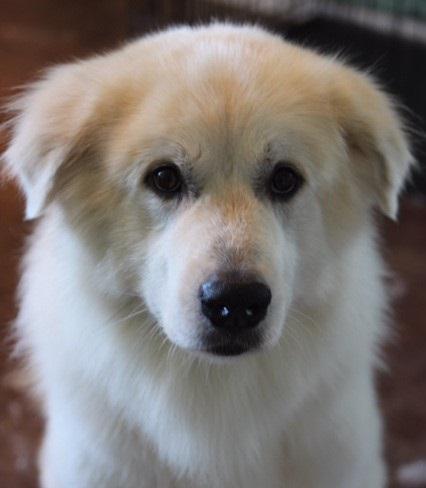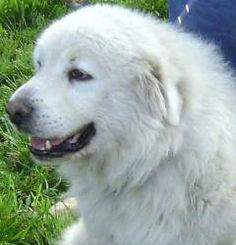The first image is the image on the left, the second image is the image on the right. Examine the images to the left and right. Is the description "The images together contain no more than two dogs." accurate? Answer yes or no. Yes. The first image is the image on the left, the second image is the image on the right. Considering the images on both sides, is "There are at most two dogs." valid? Answer yes or no. Yes. 